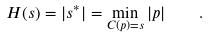<formula> <loc_0><loc_0><loc_500><loc_500>H ( s ) = | s ^ { \ast } | = \min _ { C ( p ) = s } | p | \quad .</formula> 